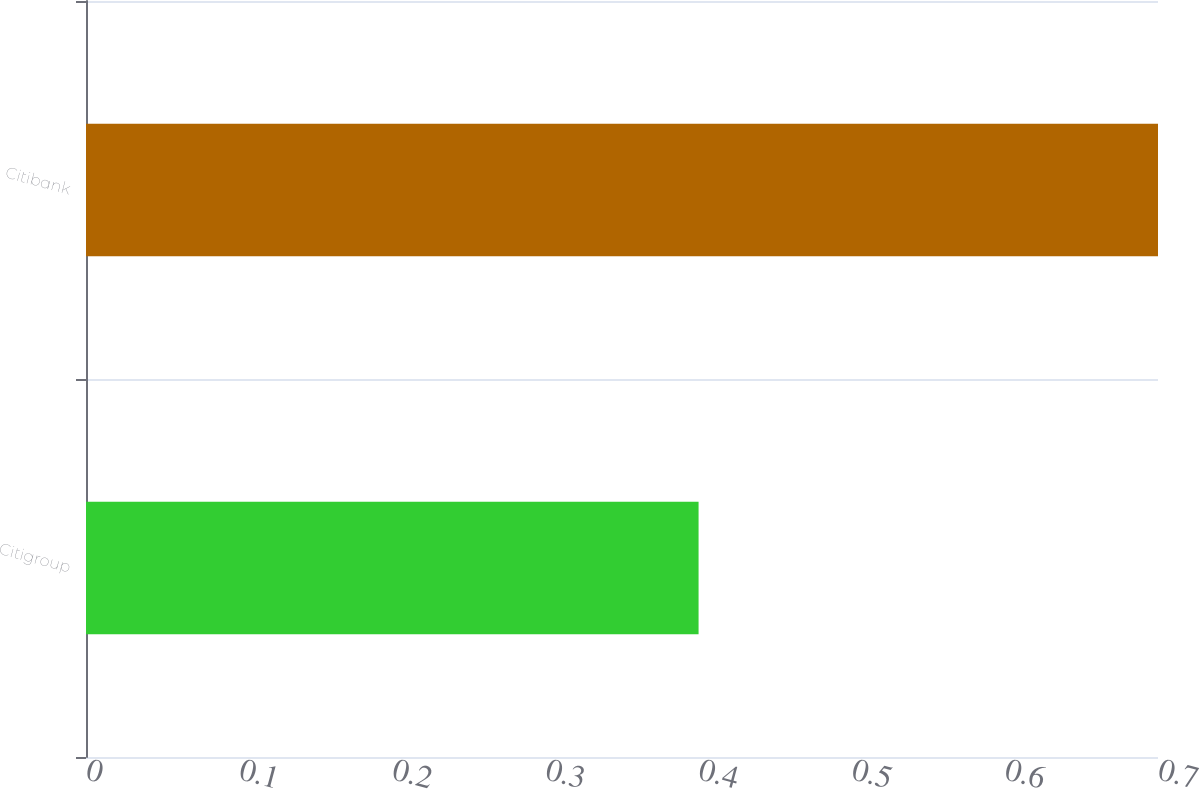Convert chart to OTSL. <chart><loc_0><loc_0><loc_500><loc_500><bar_chart><fcel>Citigroup<fcel>Citibank<nl><fcel>0.4<fcel>0.7<nl></chart> 